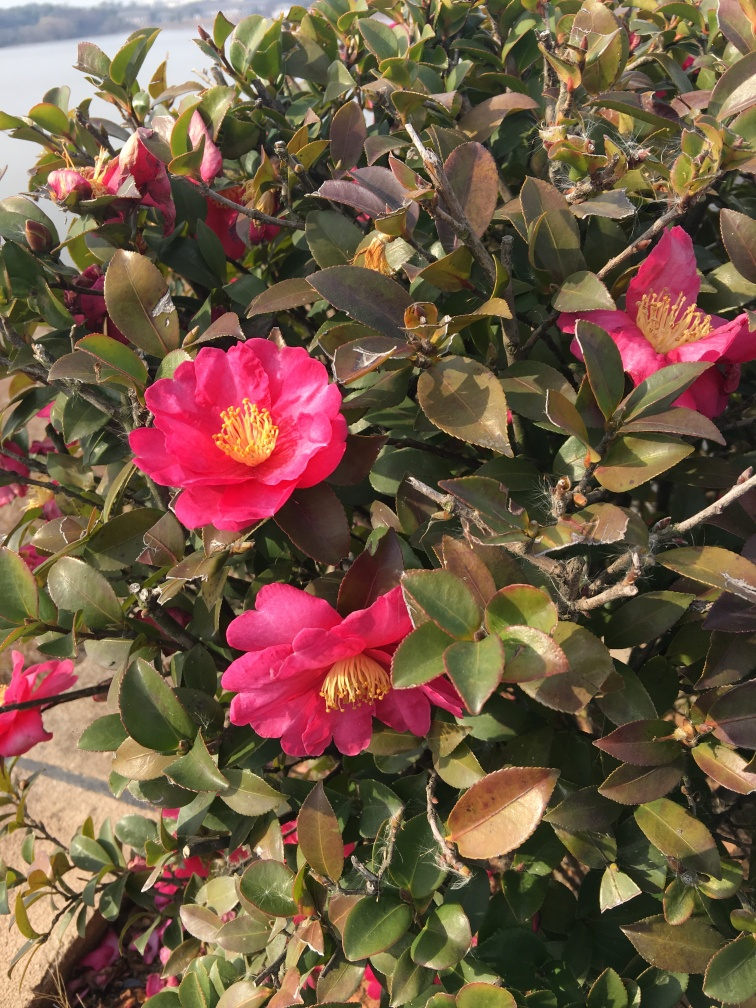What is the main subject of the image?
A. The main subject of the image is roses.
B. The main subject of the image is camellia flowers and leaves.
C. The main subject of the image is a tree.
Answer with the option's letter from the given choices directly.
 B. 